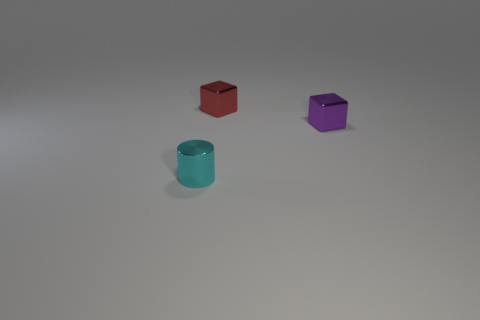Is the number of small cyan things greater than the number of large red objects?
Provide a succinct answer. Yes. What is the tiny red cube made of?
Ensure brevity in your answer.  Metal. Do the shiny block on the left side of the purple metal cube and the purple metallic block have the same size?
Provide a succinct answer. Yes. What size is the block that is right of the tiny red shiny block?
Offer a terse response. Small. Are there any other things that have the same material as the small red block?
Give a very brief answer. Yes. How many large gray cubes are there?
Keep it short and to the point. 0. What color is the tiny object that is both in front of the red metal cube and to the left of the small purple metal block?
Offer a very short reply. Cyan. Are there any red metal blocks in front of the small cyan cylinder?
Provide a short and direct response. No. There is a metallic block to the left of the purple cube; what number of small shiny cylinders are to the right of it?
Offer a very short reply. 0. There is a block that is the same material as the tiny purple thing; what size is it?
Provide a short and direct response. Small. 